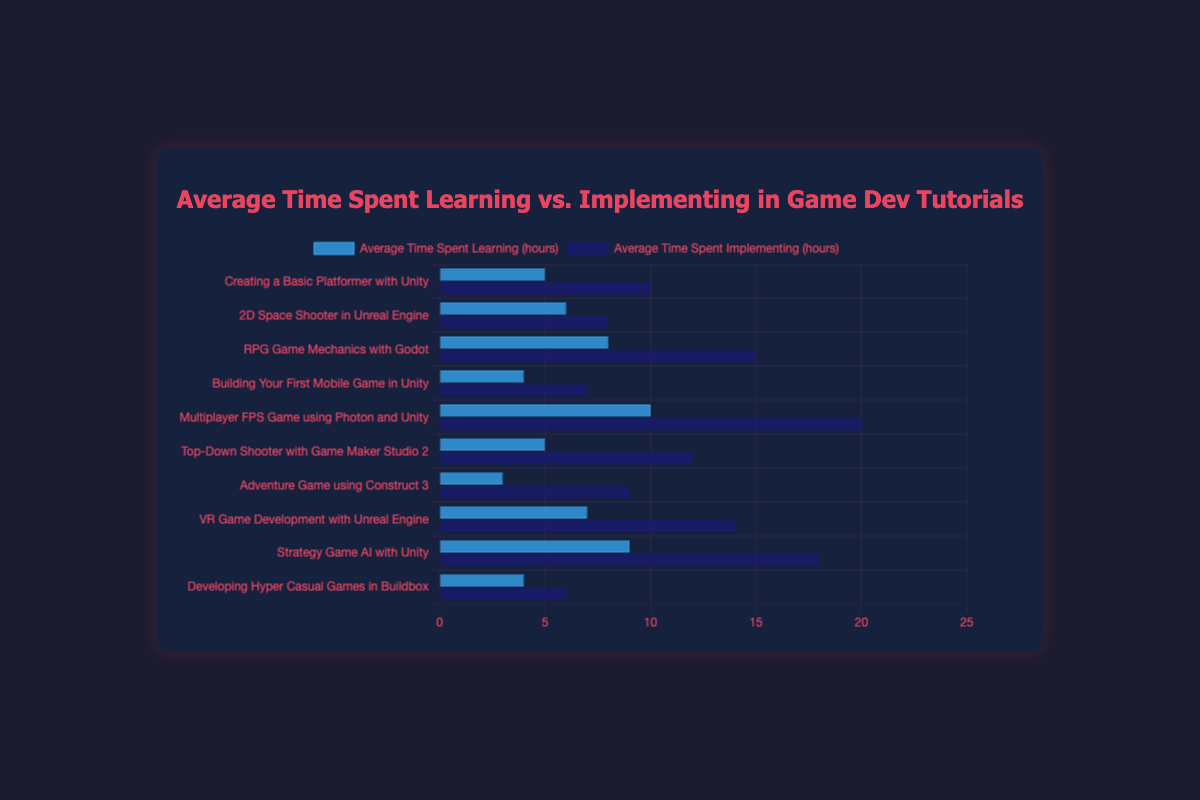What is the average time spent implementing for the "Multiplayer FPS Game using Photon and Unity" tutorial? The data for the "Multiplayer FPS Game using Photon and Unity" tutorial shows that the average time spent implementing is represented by the height of the dark blue bar for this tutorial. This value is 20 hours.
Answer: 20 hours Which tutorial has the highest average time spent learning? By visually comparing the heights of the blue bars for average time spent learning for all tutorials, the "Multiplayer FPS Game using Photon and Unity" has the tallest bar. This indicates the highest average time spent learning, which is 10 hours.
Answer: Multiplayer FPS Game using Photon and Unity What is the sum of average time spent learning and implementing for the "RPG Game Mechanics with Godot" tutorial? For the "RPG Game Mechanics with Godot" tutorial, the average time spent learning is 8 hours, and the average time spent implementing is 15 hours. Summing these, 8 + 15 = 23 hours.
Answer: 23 hours Which tutorial has the lowest average time spent learning? By examining the heights of the blue bars for all tutorials, the shortest bar represents the "Adventure Game using Construct 3" tutorial, with an average time spent learning of 3 hours.
Answer: Adventure Game using Construct 3 Is the average time spent implementing always greater than the average time spent learning across all tutorials? For each tutorial, compare the height of the dark blue bar (implementing) with the blue bar (learning). In every case, the dark blue bar is taller than the blue bar, indicating that the implementing time is always greater.
Answer: Yes What is the total average time spent implementing across all tutorials? Summing the average implementing times for all tutorials: 10 + 8 + 15 + 7 + 20 + 12 + 9 + 14 + 18 + 6 = 119 hours.
Answer: 119 hours Which tutorial shows the smallest difference between average learning and implementing times, and what is the value of that difference? Subtract the learning time from the implementing time for each tutorial. The "Developing Hyper Casual Games in Buildbox" tutorial has a difference of 6 - 4 = 2 hours, which is the smallest difference.
Answer: Developing Hyper Casual Games in Buildbox, 2 hours What is the ratio of average implementing time to average learning time for the "Top-Down Shooter with Game Maker Studio 2" tutorial? For the "Top-Down Shooter with Game Maker Studio 2" tutorial, the average implementing time is 12 hours and learning time is 5 hours. The ratio is 12 / 5 = 2.4.
Answer: 2.4 